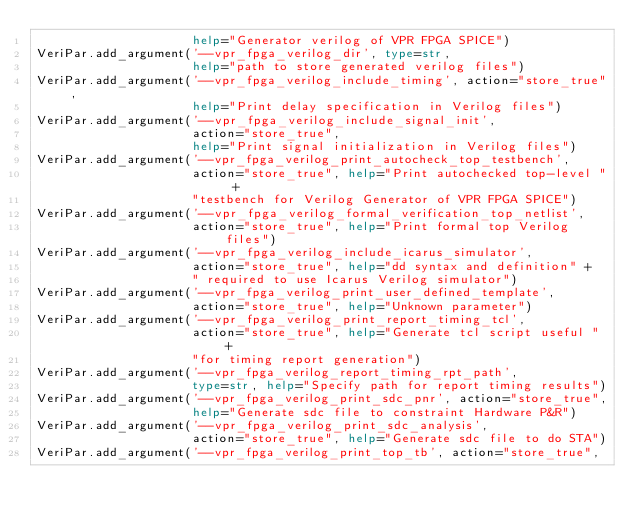<code> <loc_0><loc_0><loc_500><loc_500><_Python_>                     help="Generator verilog of VPR FPGA SPICE")
VeriPar.add_argument('--vpr_fpga_verilog_dir', type=str,
                     help="path to store generated verilog files")
VeriPar.add_argument('--vpr_fpga_verilog_include_timing', action="store_true",
                     help="Print delay specification in Verilog files")
VeriPar.add_argument('--vpr_fpga_verilog_include_signal_init',
                     action="store_true",
                     help="Print signal initialization in Verilog files")
VeriPar.add_argument('--vpr_fpga_verilog_print_autocheck_top_testbench',
                     action="store_true", help="Print autochecked top-level " +
                     "testbench for Verilog Generator of VPR FPGA SPICE")
VeriPar.add_argument('--vpr_fpga_verilog_formal_verification_top_netlist',
                     action="store_true", help="Print formal top Verilog files")
VeriPar.add_argument('--vpr_fpga_verilog_include_icarus_simulator',
                     action="store_true", help="dd syntax and definition" +
                     " required to use Icarus Verilog simulator")
VeriPar.add_argument('--vpr_fpga_verilog_print_user_defined_template',
                     action="store_true", help="Unknown parameter")
VeriPar.add_argument('--vpr_fpga_verilog_print_report_timing_tcl',
                     action="store_true", help="Generate tcl script useful " +
                     "for timing report generation")
VeriPar.add_argument('--vpr_fpga_verilog_report_timing_rpt_path',
                     type=str, help="Specify path for report timing results")
VeriPar.add_argument('--vpr_fpga_verilog_print_sdc_pnr', action="store_true",
                     help="Generate sdc file to constraint Hardware P&R")
VeriPar.add_argument('--vpr_fpga_verilog_print_sdc_analysis',
                     action="store_true", help="Generate sdc file to do STA")
VeriPar.add_argument('--vpr_fpga_verilog_print_top_tb', action="store_true",</code> 